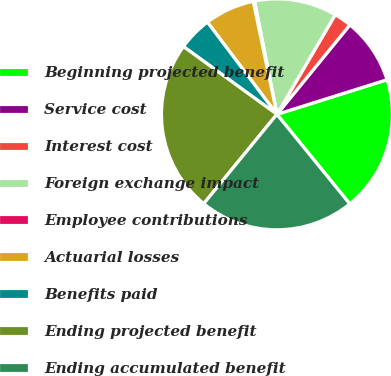<chart> <loc_0><loc_0><loc_500><loc_500><pie_chart><fcel>Beginning projected benefit<fcel>Service cost<fcel>Interest cost<fcel>Foreign exchange impact<fcel>Employee contributions<fcel>Actuarial losses<fcel>Benefits paid<fcel>Ending projected benefit<fcel>Ending accumulated benefit<nl><fcel>18.98%<fcel>9.26%<fcel>2.46%<fcel>11.53%<fcel>0.19%<fcel>6.99%<fcel>4.73%<fcel>24.06%<fcel>21.79%<nl></chart> 